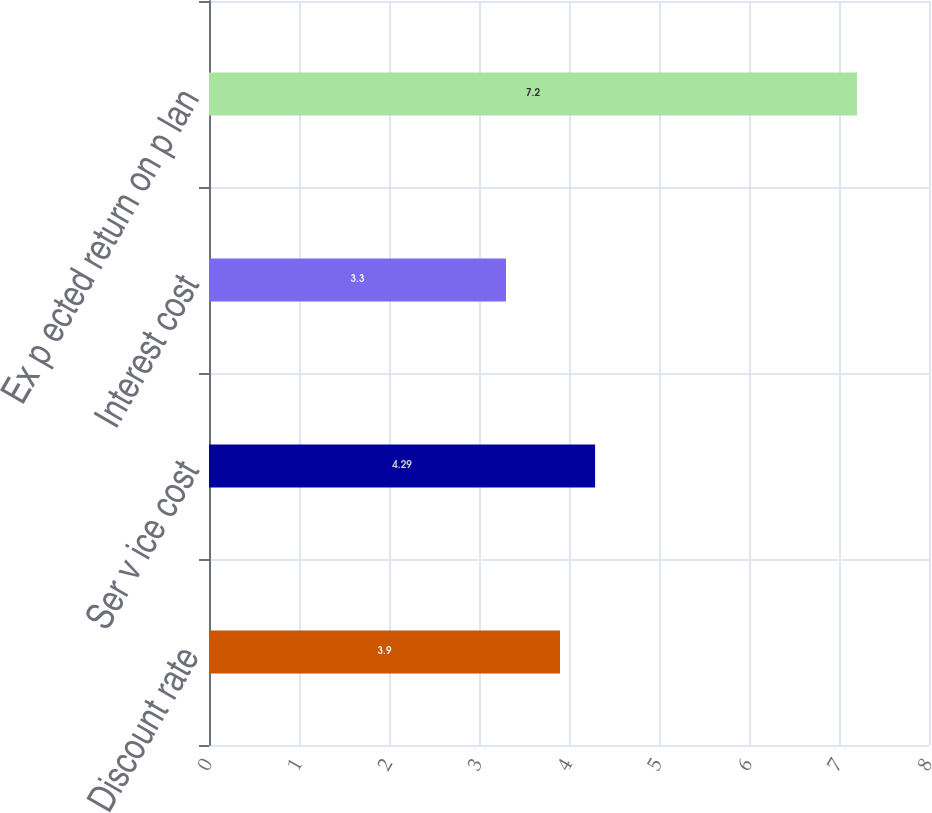Convert chart to OTSL. <chart><loc_0><loc_0><loc_500><loc_500><bar_chart><fcel>Discount rate<fcel>Ser v ice cost<fcel>Interest cost<fcel>Ex p ected return on p lan<nl><fcel>3.9<fcel>4.29<fcel>3.3<fcel>7.2<nl></chart> 